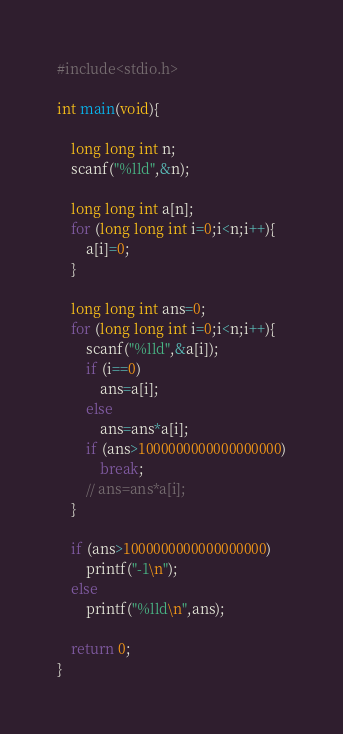<code> <loc_0><loc_0><loc_500><loc_500><_C_>#include<stdio.h>

int main(void){

    long long int n;
    scanf("%lld",&n);

    long long int a[n];
    for (long long int i=0;i<n;i++){
        a[i]=0;
    }

    long long int ans=0;
    for (long long int i=0;i<n;i++){
        scanf("%lld",&a[i]);
        if (i==0)
            ans=a[i];
        else
            ans=ans*a[i];
        if (ans>1000000000000000000)
            break;
        // ans=ans*a[i];
    }

    if (ans>1000000000000000000)
        printf("-1\n");
    else
        printf("%lld\n",ans);
    
    return 0;
}</code> 